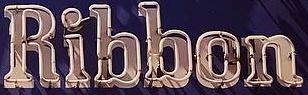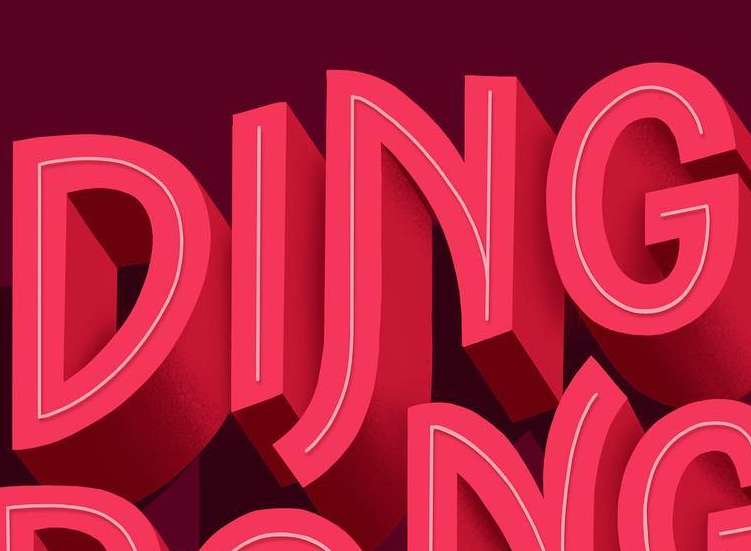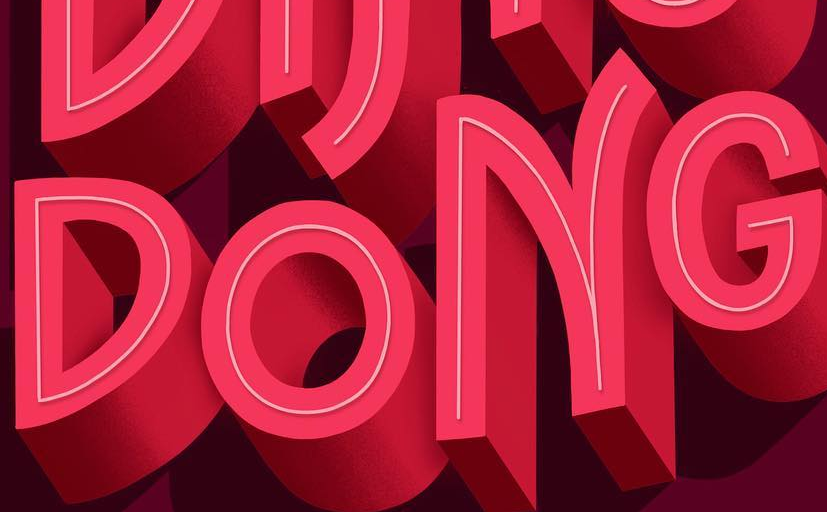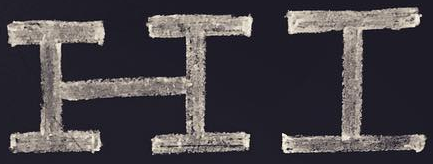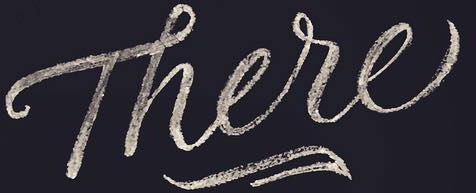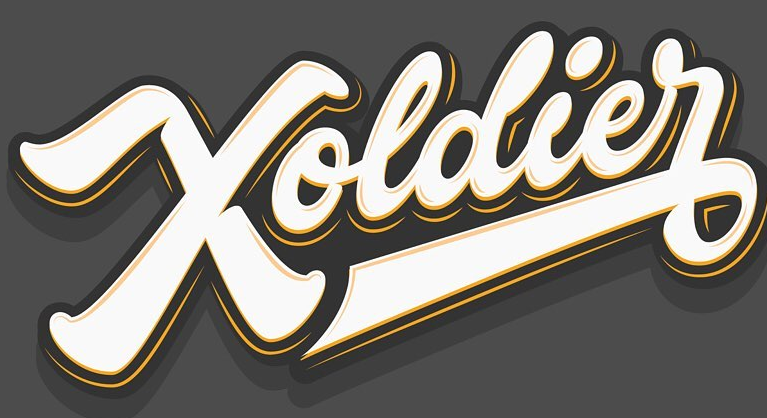What words are shown in these images in order, separated by a semicolon? Ribbon; DING; DONG; HI; There; Xoldier 